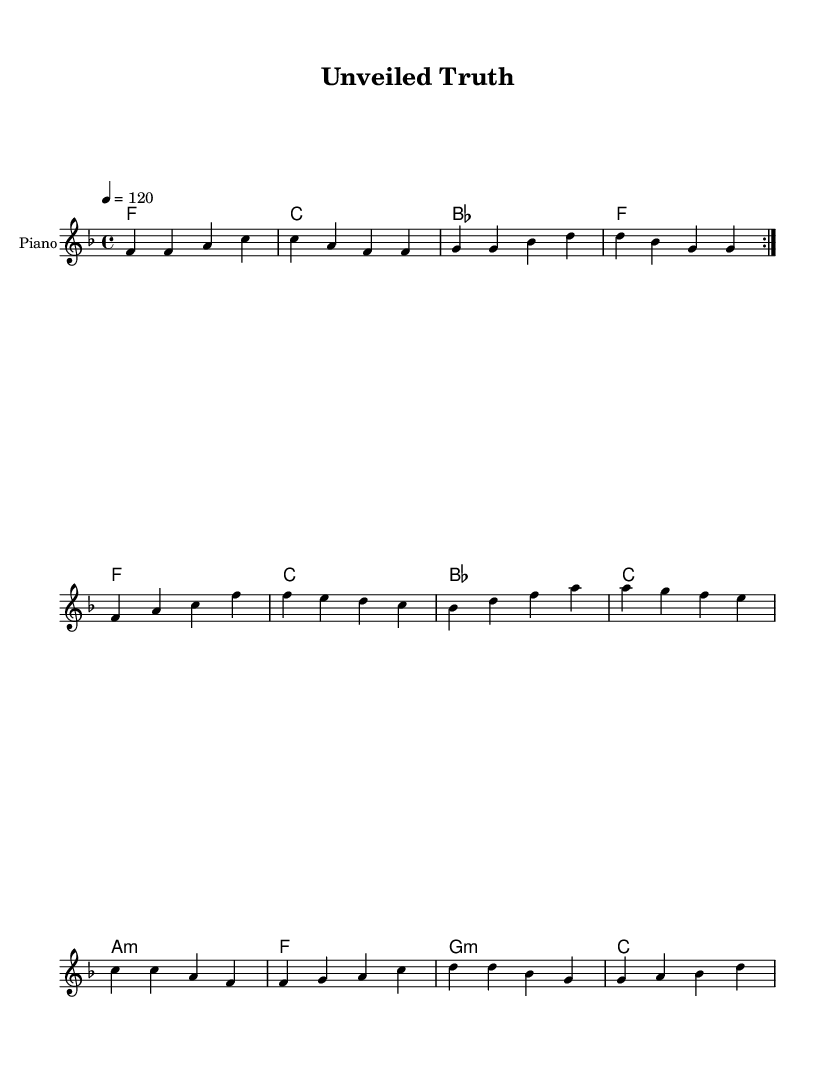What is the key signature of this music? The key signature is F major, indicated at the beginning of the sheet music, and it features one flat (B♭).
Answer: F major What is the time signature of this music? The time signature is 4/4, shown at the beginning, which means there are four beats per measure.
Answer: 4/4 What is the tempo marking of this music? The tempo marking indicates a speed of 120 beats per minute, which is typical for upbeat rhythms.
Answer: 120 How many repetitions are indicated in the melody? The melody contains a repeat, indicated by the volta marking, showing that the previous section is played two times before continuing.
Answer: 2 What is the primary theme expressed in the lyrics? The lyrics explore themes of personal revelation and emotional complexity, focusing on the shock of discovering a sibling's secret life and the feelings of admiration intertwined with betrayal.
Answer: Personal revelation What type of chords are primarily used in the harmonies? The harmonies mainly utilize major and minor chords within a pattern that supports the soulful feel of the rhythm and blues genre, aligning with the song's themes.
Answer: Major and minor chords What is the function of the bridge in the song structure? The bridge serves as a transitional section that highlights the journey toward understanding and personal growth, creating contrast with the verse and chorus.
Answer: Transitional section 